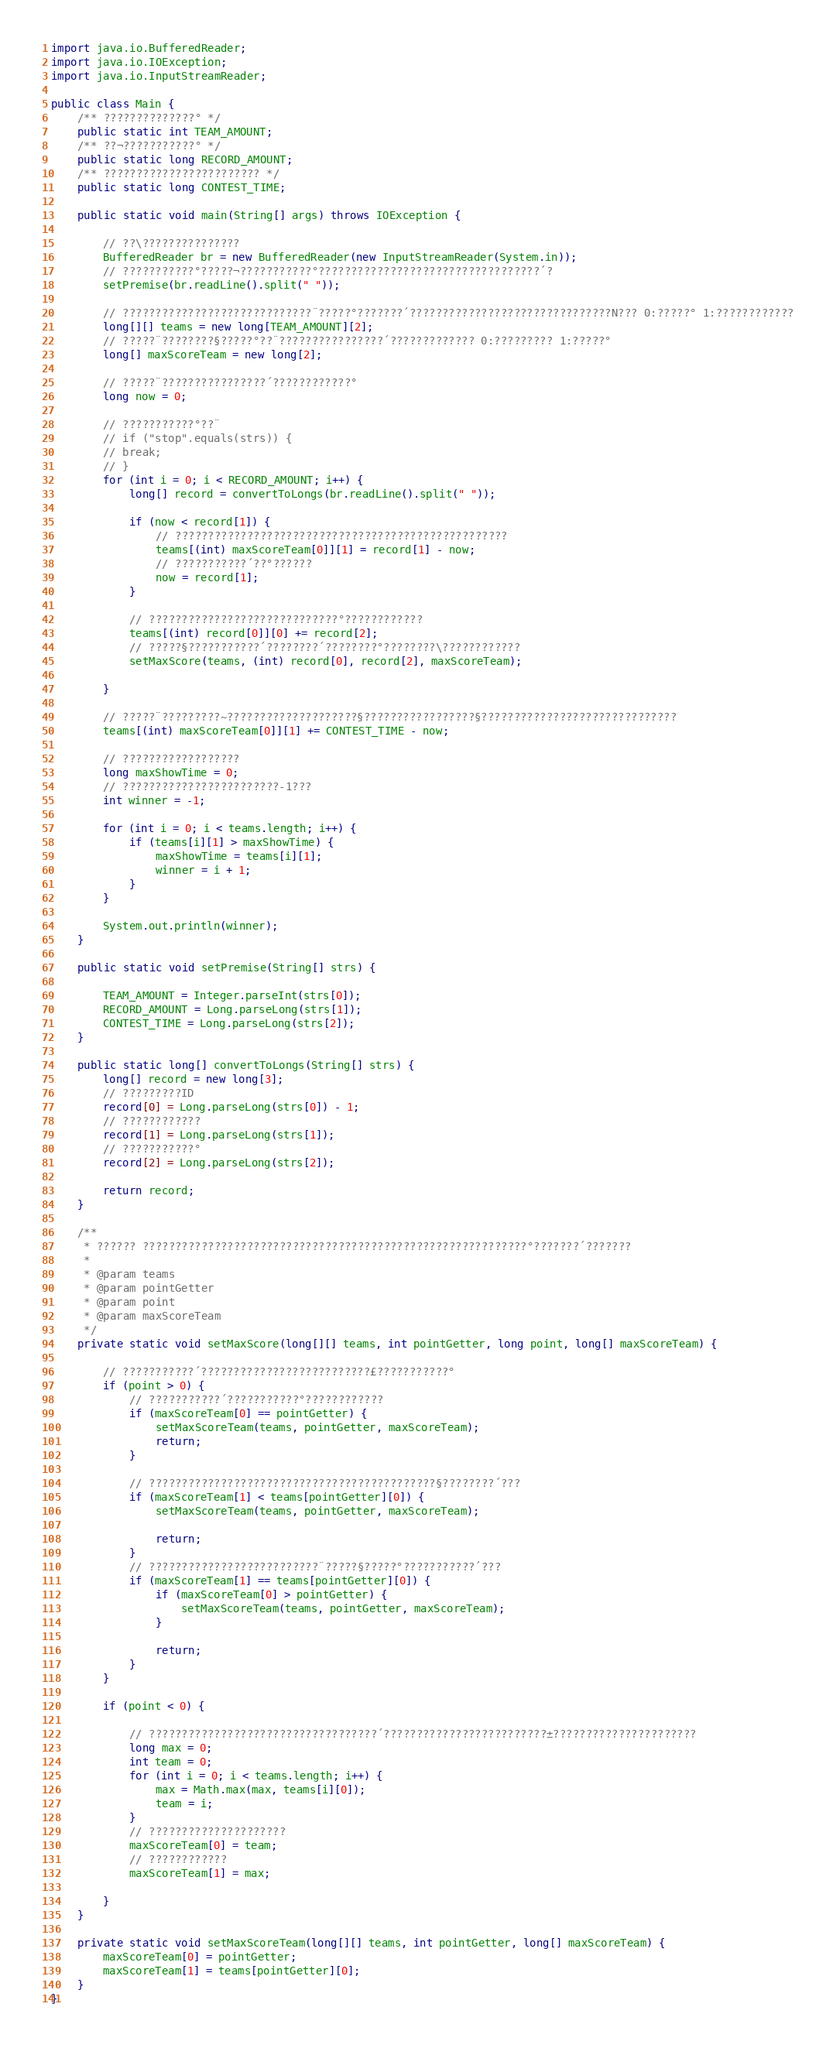Convert code to text. <code><loc_0><loc_0><loc_500><loc_500><_Java_>import java.io.BufferedReader;
import java.io.IOException;
import java.io.InputStreamReader;

public class Main {
    /** ??????????????° */
    public static int TEAM_AMOUNT;
    /** ??¬???????????° */
    public static long RECORD_AMOUNT;
    /** ???????????????????????? */
    public static long CONTEST_TIME;

    public static void main(String[] args) throws IOException {

        // ??\???????????????
        BufferedReader br = new BufferedReader(new InputStreamReader(System.in));
        // ???????????°?????¬???????????°??????????????????????????????????´?
        setPremise(br.readLine().split(" "));

        // ?????????????????????????????¨?????°???????´???????????????????????????????N??? 0:?????° 1:????????????
        long[][] teams = new long[TEAM_AMOUNT][2];
        // ?????¨????????§?????°??¨????????????????´????????????? 0:????????? 1:?????°
        long[] maxScoreTeam = new long[2];

        // ?????¨????????????????´????????????°
        long now = 0;

        // ???????????°??¨
        // if ("stop".equals(strs)) {
        // break;
        // }
        for (int i = 0; i < RECORD_AMOUNT; i++) {
            long[] record = convertToLongs(br.readLine().split(" "));

            if (now < record[1]) {
                // ???????????????????????????????????????????????????
                teams[(int) maxScoreTeam[0]][1] = record[1] - now;
                // ???????????´??°??????
                now = record[1];
            }

            // ?????????????????????????????°????????????
            teams[(int) record[0]][0] += record[2];
            // ?????§???????????´????????´????????°????????\????????????
            setMaxScore(teams, (int) record[0], record[2], maxScoreTeam);

        }

        // ?????¨?????????~????????????????????§?????????????????§??????????????????????????????
        teams[(int) maxScoreTeam[0]][1] += CONTEST_TIME - now;

        // ??????????????????
        long maxShowTime = 0;
        // ????????????????????????-1???
        int winner = -1;

        for (int i = 0; i < teams.length; i++) {
            if (teams[i][1] > maxShowTime) {
                maxShowTime = teams[i][1];
                winner = i + 1;
            }
        }

        System.out.println(winner);
    }

    public static void setPremise(String[] strs) {

        TEAM_AMOUNT = Integer.parseInt(strs[0]);
        RECORD_AMOUNT = Long.parseLong(strs[1]);
        CONTEST_TIME = Long.parseLong(strs[2]);
    }

    public static long[] convertToLongs(String[] strs) {
        long[] record = new long[3];
        // ?????????ID
        record[0] = Long.parseLong(strs[0]) - 1;
        // ????????????
        record[1] = Long.parseLong(strs[1]);
        // ???????????°
        record[2] = Long.parseLong(strs[2]);

        return record;
    }

    /**
     * ?????? ???????????????????????????????????????????????????????????°???????´???????
     * 
     * @param teams
     * @param pointGetter
     * @param point
     * @param maxScoreTeam
     */
    private static void setMaxScore(long[][] teams, int pointGetter, long point, long[] maxScoreTeam) {

        // ???????????´??????????????????????????£???????????°
        if (point > 0) {
            // ???????????´???????????°????????????
            if (maxScoreTeam[0] == pointGetter) {
                setMaxScoreTeam(teams, pointGetter, maxScoreTeam);
                return;
            }

            // ????????????????????????????????????????????§????????´???
            if (maxScoreTeam[1] < teams[pointGetter][0]) {
                setMaxScoreTeam(teams, pointGetter, maxScoreTeam);

                return;
            }
            // ??????????????????????????¨?????§?????°???????????´???
            if (maxScoreTeam[1] == teams[pointGetter][0]) {
                if (maxScoreTeam[0] > pointGetter) {
                    setMaxScoreTeam(teams, pointGetter, maxScoreTeam);
                }

                return;
            }
        }

        if (point < 0) {

            // ???????????????????????????????????´?????????????????????????±??????????????????????
            long max = 0;
            int team = 0;
            for (int i = 0; i < teams.length; i++) {
                max = Math.max(max, teams[i][0]);
                team = i;
            }
            // ?????????????????????
            maxScoreTeam[0] = team;
            // ????????????
            maxScoreTeam[1] = max;

        }
    }

    private static void setMaxScoreTeam(long[][] teams, int pointGetter, long[] maxScoreTeam) {
        maxScoreTeam[0] = pointGetter;
        maxScoreTeam[1] = teams[pointGetter][0];
    }
}</code> 